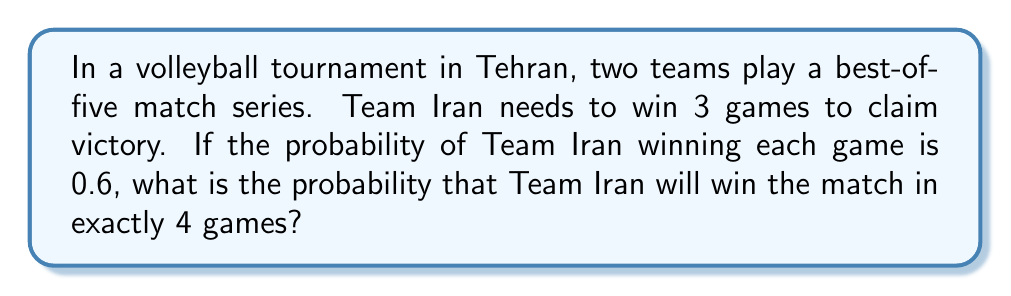Can you solve this math problem? Let's approach this step-by-step using combinatorics:

1) For Team Iran to win in exactly 4 games, they need to win 3 games and lose 1 game out of the first 4 games.

2) We can use the combination formula to calculate the number of ways this can happen:
   $$\binom{4}{3} = \frac{4!}{3!(4-3)!} = \frac{4!}{3!1!} = 4$$

3) The probability of winning each game is 0.6, so the probability of losing is 1 - 0.6 = 0.4.

4) The probability of a specific sequence of 3 wins and 1 loss is:
   $$(0.6)^3 \cdot (0.4)^1 = 0.0864$$

5) Since there are 4 ways this can happen (calculated in step 2), and each way has a probability of 0.0864, we multiply:

   $$4 \cdot 0.0864 = 0.3456$$

Therefore, the probability of Team Iran winning the match in exactly 4 games is 0.3456 or about 34.56%.
Answer: 0.3456 